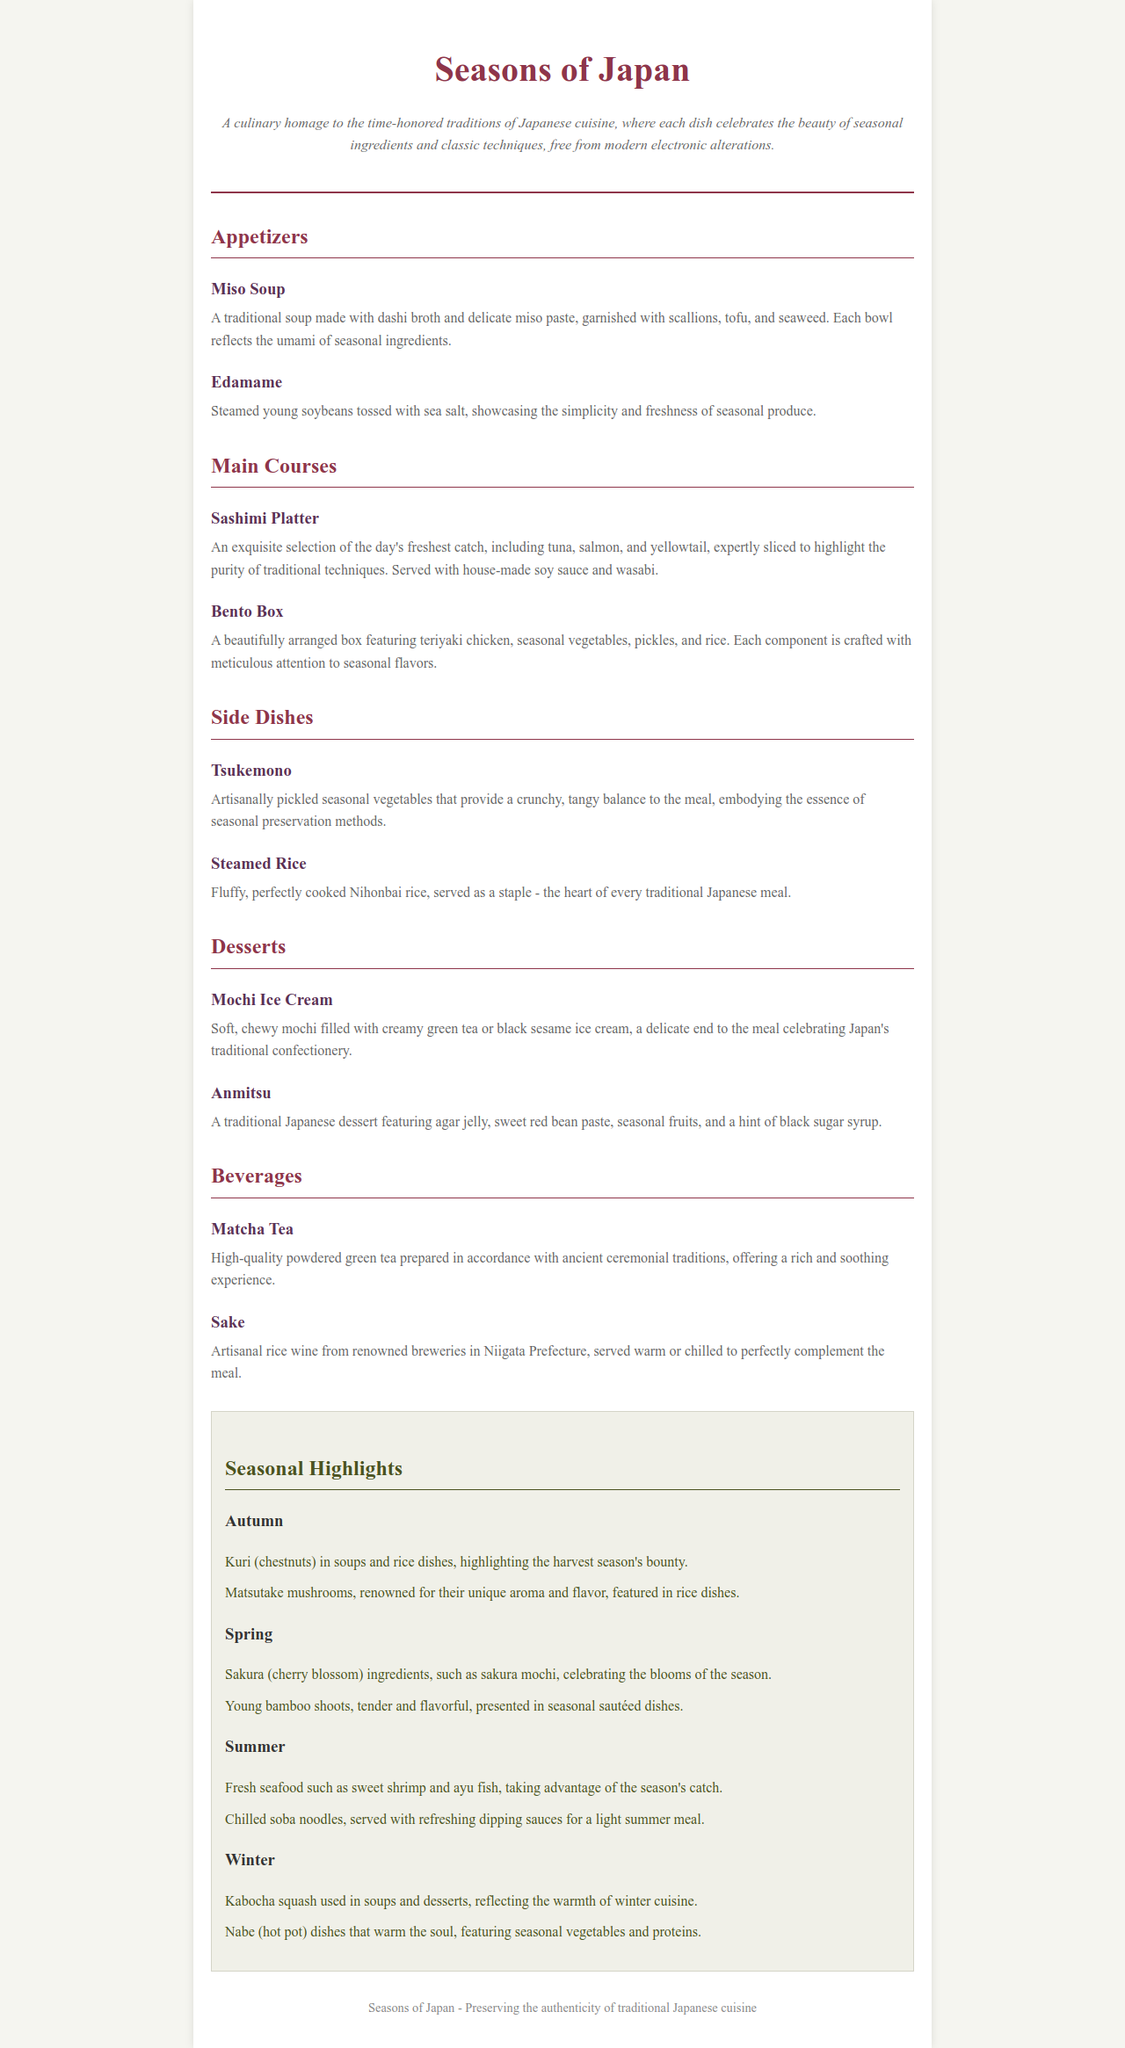What type of tea is mentioned in the beverages section? The beverages section highlights specific types of drinks offered, including tea, specifically Matcha Tea.
Answer: Matcha Tea What ingredients are featured in the Autumn seasonal highlights? The Autumn section lists particular seasonal ingredients like kuri and matsutake mushrooms used in Japanese cuisine.
Answer: Kuri, Matsutake mushrooms How many main courses are listed on the menu? The menu has a specific section for main courses and includes two distinct items, which can be counted.
Answer: 2 What is served with the Sashimi Platter? The Sashimi Platter is complemented by important traditional condiments, specifically house-made soy sauce and wasabi.
Answer: House-made soy sauce and wasabi Which dessert features agar jelly? Among the desserts listed, Anmitsu is identified to contain agar jelly as a key component in its preparation.
Answer: Anmitsu What kind of rice accompanies a traditional Japanese meal? The description of Steamed Rice indicates it as a staple in traditional meals, thus providing insight into its significance.
Answer: Nihonbai rice What is the seasonal ingredient for Spring identified in the menu? In the Spring highlights, specific seasonal elements like sakura and young bamboo shoots are noted for their preparation in various dishes.
Answer: Sakura, young bamboo shoots Which side dish is made from pickled vegetables? The menu explicitly names a side dish designed to provide a crunchy texture alongside the meal, namely Tsukemono.
Answer: Tsukemono 